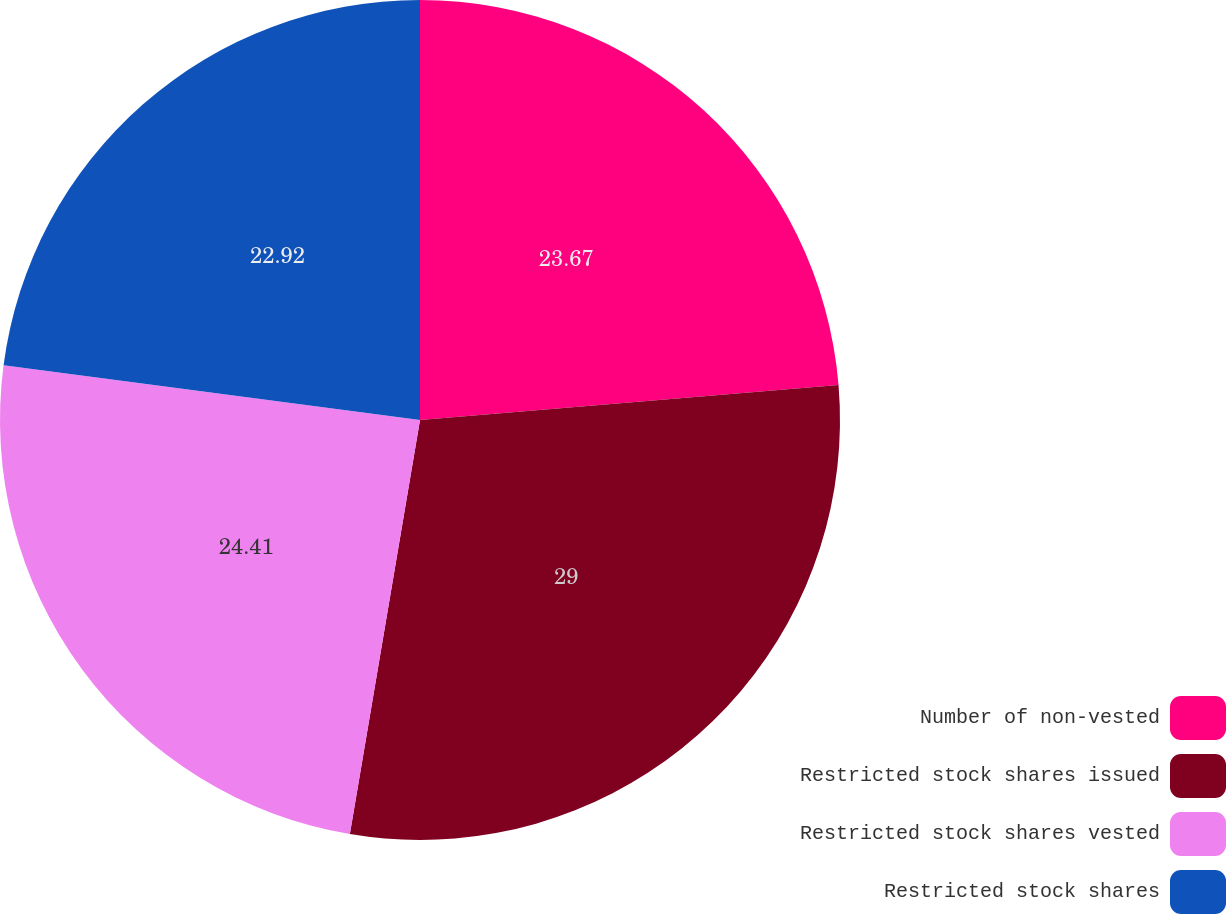<chart> <loc_0><loc_0><loc_500><loc_500><pie_chart><fcel>Number of non-vested<fcel>Restricted stock shares issued<fcel>Restricted stock shares vested<fcel>Restricted stock shares<nl><fcel>23.67%<fcel>29.0%<fcel>24.41%<fcel>22.92%<nl></chart> 